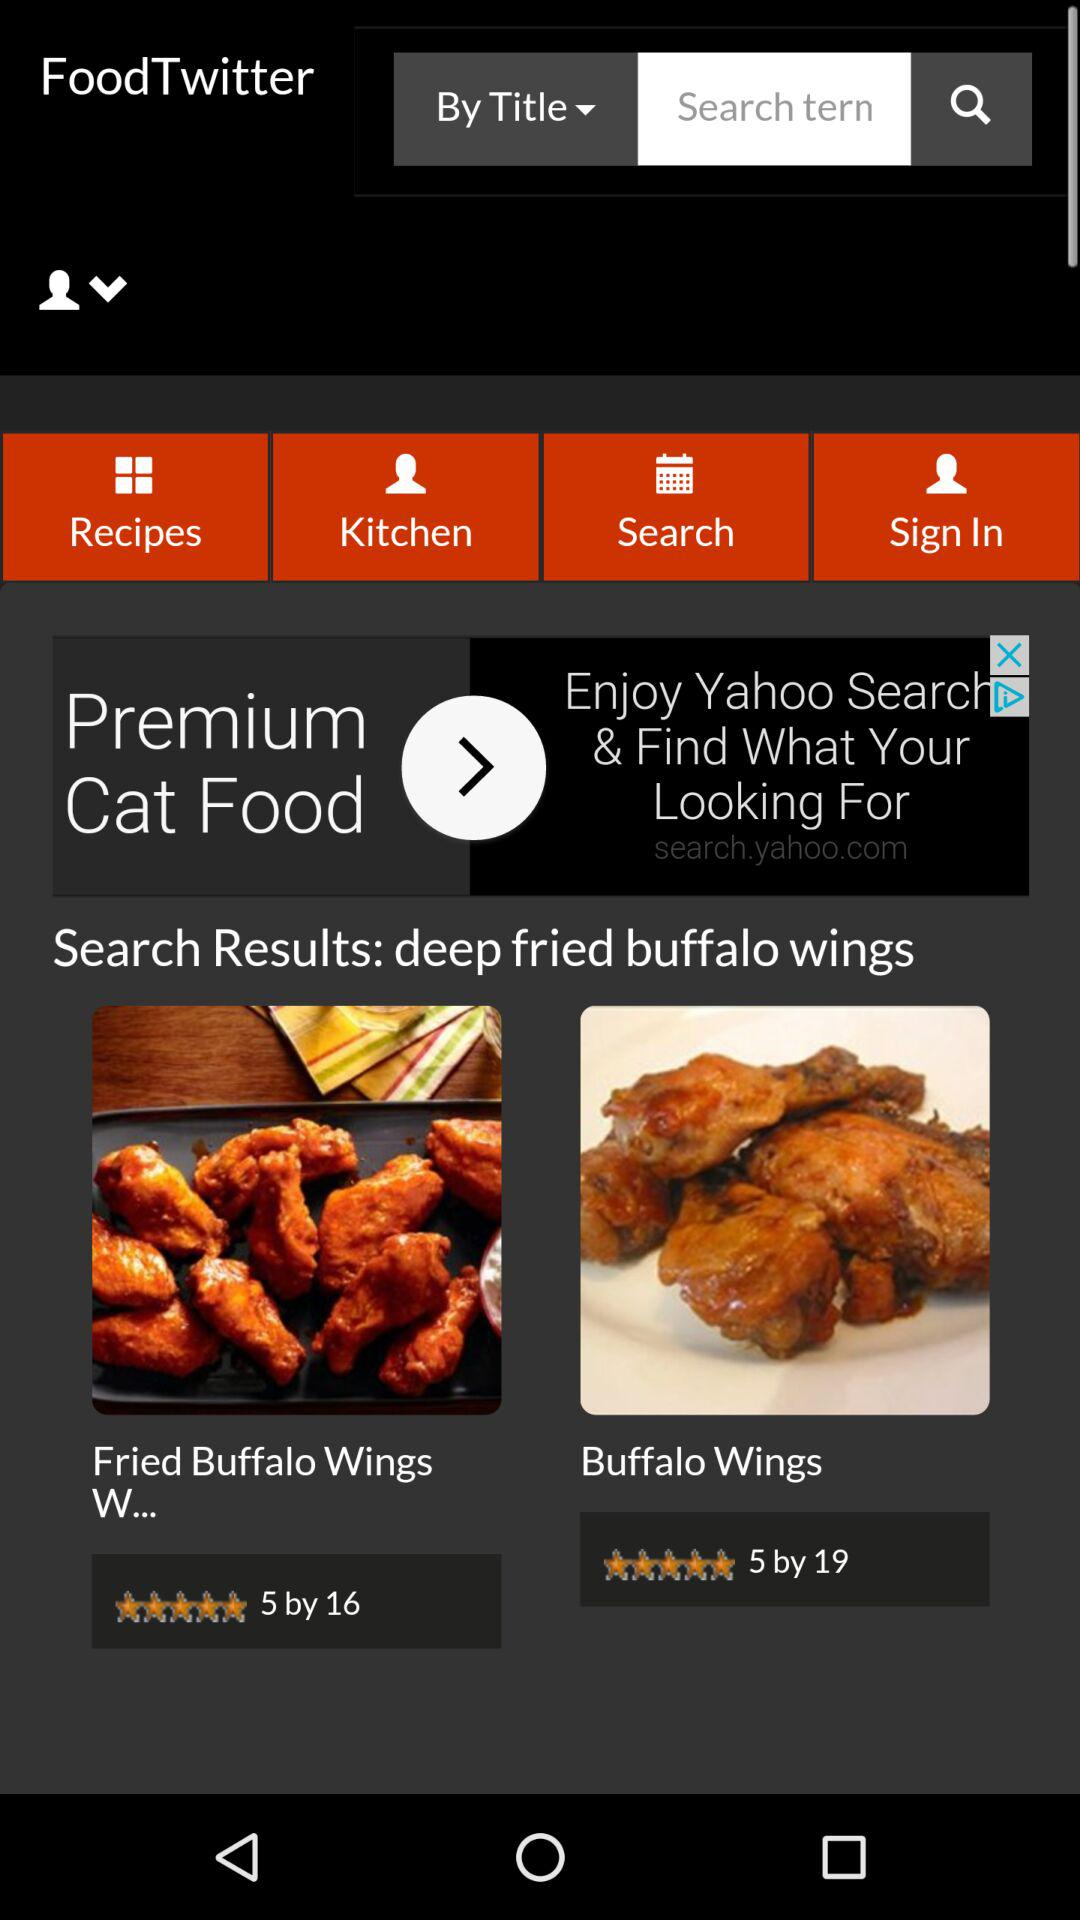How many recipes are displayed?
Answer the question using a single word or phrase. 2 